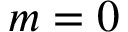Convert formula to latex. <formula><loc_0><loc_0><loc_500><loc_500>m = 0</formula> 